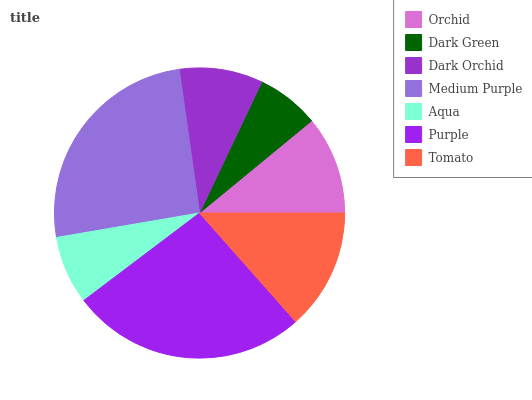Is Dark Green the minimum?
Answer yes or no. Yes. Is Purple the maximum?
Answer yes or no. Yes. Is Dark Orchid the minimum?
Answer yes or no. No. Is Dark Orchid the maximum?
Answer yes or no. No. Is Dark Orchid greater than Dark Green?
Answer yes or no. Yes. Is Dark Green less than Dark Orchid?
Answer yes or no. Yes. Is Dark Green greater than Dark Orchid?
Answer yes or no. No. Is Dark Orchid less than Dark Green?
Answer yes or no. No. Is Orchid the high median?
Answer yes or no. Yes. Is Orchid the low median?
Answer yes or no. Yes. Is Dark Green the high median?
Answer yes or no. No. Is Aqua the low median?
Answer yes or no. No. 